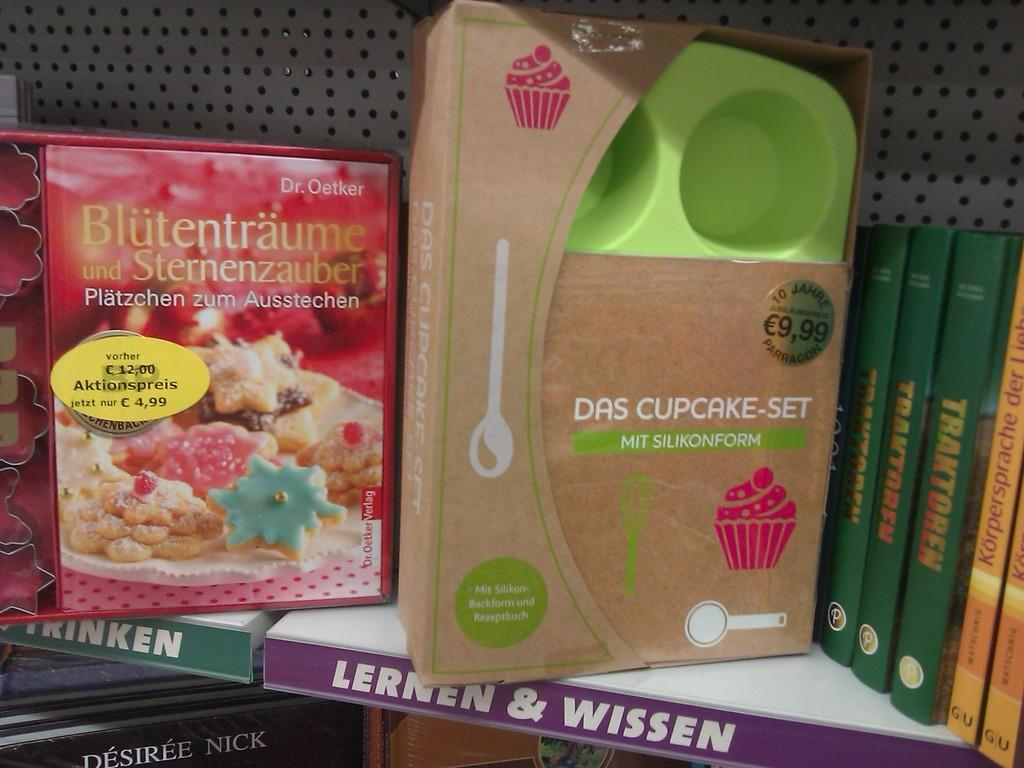<image>
Share a concise interpretation of the image provided. A shelf that displays a German cookbook for desserts and a cupcake baking set. 